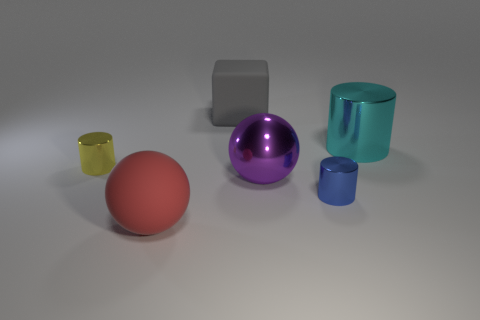There is a purple thing; is its shape the same as the metallic thing that is on the left side of the matte block?
Make the answer very short. No. Is the number of purple metallic balls that are to the left of the yellow thing greater than the number of big purple objects that are to the right of the tiny blue metallic cylinder?
Offer a very short reply. No. Is there any other thing that is the same color as the metal ball?
Ensure brevity in your answer.  No. There is a tiny blue object that is in front of the big matte thing behind the big cyan metal cylinder; is there a red rubber sphere that is behind it?
Offer a terse response. No. Do the big rubber thing behind the tiny yellow object and the yellow object have the same shape?
Offer a very short reply. No. Is the number of big cyan shiny things that are on the right side of the large gray matte object less than the number of purple balls in front of the metal sphere?
Provide a short and direct response. No. What is the material of the red sphere?
Your answer should be compact. Rubber. There is a large rubber block; does it have the same color as the big metallic object that is in front of the tiny yellow cylinder?
Your response must be concise. No. How many large cyan metal things are in front of the purple metal object?
Provide a short and direct response. 0. Are there fewer gray blocks that are in front of the yellow thing than small shiny things?
Keep it short and to the point. Yes. 